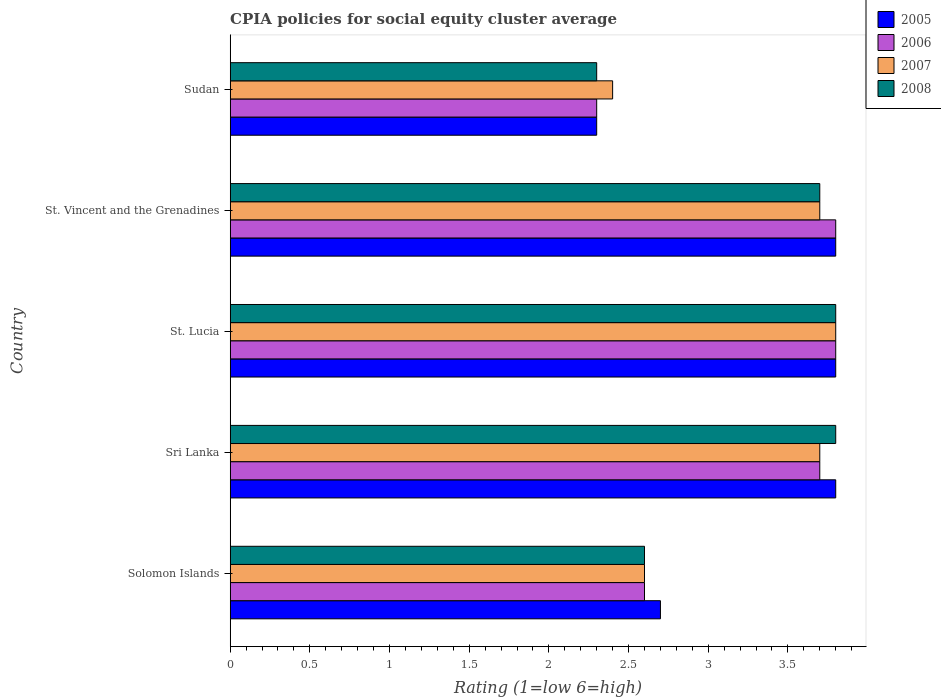How many different coloured bars are there?
Your answer should be very brief. 4. How many groups of bars are there?
Ensure brevity in your answer.  5. Are the number of bars per tick equal to the number of legend labels?
Your answer should be compact. Yes. Are the number of bars on each tick of the Y-axis equal?
Give a very brief answer. Yes. How many bars are there on the 4th tick from the top?
Your answer should be very brief. 4. How many bars are there on the 3rd tick from the bottom?
Provide a short and direct response. 4. What is the label of the 2nd group of bars from the top?
Provide a succinct answer. St. Vincent and the Grenadines. In how many cases, is the number of bars for a given country not equal to the number of legend labels?
Offer a terse response. 0. What is the CPIA rating in 2006 in Solomon Islands?
Provide a short and direct response. 2.6. In which country was the CPIA rating in 2005 maximum?
Make the answer very short. Sri Lanka. In which country was the CPIA rating in 2006 minimum?
Offer a terse response. Sudan. What is the total CPIA rating in 2008 in the graph?
Make the answer very short. 16.2. What is the difference between the CPIA rating in 2005 in Sri Lanka and that in St. Vincent and the Grenadines?
Offer a very short reply. 0. What is the difference between the CPIA rating in 2008 in St. Lucia and the CPIA rating in 2007 in Solomon Islands?
Make the answer very short. 1.2. What is the average CPIA rating in 2006 per country?
Provide a succinct answer. 3.24. What is the difference between the CPIA rating in 2005 and CPIA rating in 2007 in Solomon Islands?
Your answer should be compact. 0.1. In how many countries, is the CPIA rating in 2008 greater than 1.9 ?
Give a very brief answer. 5. What is the ratio of the CPIA rating in 2006 in Solomon Islands to that in Sri Lanka?
Provide a succinct answer. 0.7. Is the CPIA rating in 2005 in St. Vincent and the Grenadines less than that in Sudan?
Ensure brevity in your answer.  No. Is the difference between the CPIA rating in 2005 in Solomon Islands and Sudan greater than the difference between the CPIA rating in 2007 in Solomon Islands and Sudan?
Your response must be concise. Yes. What is the difference between the highest and the second highest CPIA rating in 2005?
Your answer should be very brief. 0. What is the difference between the highest and the lowest CPIA rating in 2005?
Give a very brief answer. 1.5. Is the sum of the CPIA rating in 2007 in Sri Lanka and Sudan greater than the maximum CPIA rating in 2005 across all countries?
Provide a succinct answer. Yes. Is it the case that in every country, the sum of the CPIA rating in 2007 and CPIA rating in 2005 is greater than the sum of CPIA rating in 2006 and CPIA rating in 2008?
Your answer should be compact. No. How many bars are there?
Offer a terse response. 20. How many countries are there in the graph?
Provide a short and direct response. 5. What is the difference between two consecutive major ticks on the X-axis?
Your answer should be compact. 0.5. Are the values on the major ticks of X-axis written in scientific E-notation?
Ensure brevity in your answer.  No. Does the graph contain any zero values?
Your response must be concise. No. Does the graph contain grids?
Give a very brief answer. No. Where does the legend appear in the graph?
Provide a succinct answer. Top right. How many legend labels are there?
Your answer should be very brief. 4. What is the title of the graph?
Your answer should be very brief. CPIA policies for social equity cluster average. What is the label or title of the X-axis?
Offer a terse response. Rating (1=low 6=high). What is the Rating (1=low 6=high) of 2006 in Sri Lanka?
Ensure brevity in your answer.  3.7. What is the Rating (1=low 6=high) of 2008 in Sri Lanka?
Your answer should be very brief. 3.8. What is the Rating (1=low 6=high) of 2005 in St. Lucia?
Your response must be concise. 3.8. What is the Rating (1=low 6=high) in 2006 in St. Lucia?
Your answer should be very brief. 3.8. What is the Rating (1=low 6=high) of 2007 in St. Lucia?
Provide a short and direct response. 3.8. What is the Rating (1=low 6=high) of 2006 in St. Vincent and the Grenadines?
Your response must be concise. 3.8. What is the Rating (1=low 6=high) in 2007 in St. Vincent and the Grenadines?
Your answer should be very brief. 3.7. What is the Rating (1=low 6=high) of 2008 in Sudan?
Your response must be concise. 2.3. Across all countries, what is the maximum Rating (1=low 6=high) in 2005?
Provide a short and direct response. 3.8. Across all countries, what is the minimum Rating (1=low 6=high) of 2007?
Your answer should be very brief. 2.4. What is the total Rating (1=low 6=high) in 2005 in the graph?
Give a very brief answer. 16.4. What is the total Rating (1=low 6=high) in 2006 in the graph?
Offer a terse response. 16.2. What is the total Rating (1=low 6=high) in 2008 in the graph?
Your answer should be compact. 16.2. What is the difference between the Rating (1=low 6=high) of 2005 in Solomon Islands and that in Sri Lanka?
Provide a short and direct response. -1.1. What is the difference between the Rating (1=low 6=high) of 2008 in Solomon Islands and that in Sri Lanka?
Your response must be concise. -1.2. What is the difference between the Rating (1=low 6=high) in 2005 in Solomon Islands and that in St. Lucia?
Make the answer very short. -1.1. What is the difference between the Rating (1=low 6=high) of 2006 in Solomon Islands and that in St. Lucia?
Your answer should be very brief. -1.2. What is the difference between the Rating (1=low 6=high) in 2006 in Solomon Islands and that in St. Vincent and the Grenadines?
Your response must be concise. -1.2. What is the difference between the Rating (1=low 6=high) of 2007 in Solomon Islands and that in St. Vincent and the Grenadines?
Give a very brief answer. -1.1. What is the difference between the Rating (1=low 6=high) in 2005 in Solomon Islands and that in Sudan?
Provide a succinct answer. 0.4. What is the difference between the Rating (1=low 6=high) in 2006 in Solomon Islands and that in Sudan?
Your answer should be compact. 0.3. What is the difference between the Rating (1=low 6=high) in 2007 in Solomon Islands and that in Sudan?
Give a very brief answer. 0.2. What is the difference between the Rating (1=low 6=high) of 2005 in Sri Lanka and that in St. Lucia?
Give a very brief answer. 0. What is the difference between the Rating (1=low 6=high) in 2008 in Sri Lanka and that in St. Lucia?
Offer a terse response. 0. What is the difference between the Rating (1=low 6=high) of 2005 in Sri Lanka and that in Sudan?
Your answer should be compact. 1.5. What is the difference between the Rating (1=low 6=high) of 2007 in Sri Lanka and that in Sudan?
Provide a succinct answer. 1.3. What is the difference between the Rating (1=low 6=high) of 2007 in St. Lucia and that in St. Vincent and the Grenadines?
Your answer should be very brief. 0.1. What is the difference between the Rating (1=low 6=high) of 2005 in St. Lucia and that in Sudan?
Offer a very short reply. 1.5. What is the difference between the Rating (1=low 6=high) in 2007 in St. Lucia and that in Sudan?
Offer a very short reply. 1.4. What is the difference between the Rating (1=low 6=high) of 2008 in St. Lucia and that in Sudan?
Provide a succinct answer. 1.5. What is the difference between the Rating (1=low 6=high) of 2006 in Solomon Islands and the Rating (1=low 6=high) of 2007 in Sri Lanka?
Your answer should be compact. -1.1. What is the difference between the Rating (1=low 6=high) of 2005 in Solomon Islands and the Rating (1=low 6=high) of 2007 in St. Lucia?
Make the answer very short. -1.1. What is the difference between the Rating (1=low 6=high) in 2006 in Solomon Islands and the Rating (1=low 6=high) in 2007 in St. Lucia?
Provide a succinct answer. -1.2. What is the difference between the Rating (1=low 6=high) of 2007 in Solomon Islands and the Rating (1=low 6=high) of 2008 in St. Lucia?
Make the answer very short. -1.2. What is the difference between the Rating (1=low 6=high) of 2005 in Solomon Islands and the Rating (1=low 6=high) of 2006 in St. Vincent and the Grenadines?
Provide a succinct answer. -1.1. What is the difference between the Rating (1=low 6=high) of 2005 in Solomon Islands and the Rating (1=low 6=high) of 2007 in St. Vincent and the Grenadines?
Provide a short and direct response. -1. What is the difference between the Rating (1=low 6=high) in 2005 in Solomon Islands and the Rating (1=low 6=high) in 2008 in St. Vincent and the Grenadines?
Ensure brevity in your answer.  -1. What is the difference between the Rating (1=low 6=high) of 2006 in Solomon Islands and the Rating (1=low 6=high) of 2007 in St. Vincent and the Grenadines?
Provide a short and direct response. -1.1. What is the difference between the Rating (1=low 6=high) of 2007 in Solomon Islands and the Rating (1=low 6=high) of 2008 in St. Vincent and the Grenadines?
Make the answer very short. -1.1. What is the difference between the Rating (1=low 6=high) in 2005 in Solomon Islands and the Rating (1=low 6=high) in 2006 in Sudan?
Provide a short and direct response. 0.4. What is the difference between the Rating (1=low 6=high) in 2006 in Solomon Islands and the Rating (1=low 6=high) in 2007 in Sudan?
Give a very brief answer. 0.2. What is the difference between the Rating (1=low 6=high) of 2006 in Solomon Islands and the Rating (1=low 6=high) of 2008 in Sudan?
Keep it short and to the point. 0.3. What is the difference between the Rating (1=low 6=high) in 2007 in Solomon Islands and the Rating (1=low 6=high) in 2008 in Sudan?
Ensure brevity in your answer.  0.3. What is the difference between the Rating (1=low 6=high) in 2005 in Sri Lanka and the Rating (1=low 6=high) in 2006 in St. Lucia?
Your answer should be compact. 0. What is the difference between the Rating (1=low 6=high) of 2005 in Sri Lanka and the Rating (1=low 6=high) of 2007 in St. Lucia?
Provide a succinct answer. 0. What is the difference between the Rating (1=low 6=high) of 2005 in Sri Lanka and the Rating (1=low 6=high) of 2008 in St. Lucia?
Ensure brevity in your answer.  0. What is the difference between the Rating (1=low 6=high) in 2006 in Sri Lanka and the Rating (1=low 6=high) in 2008 in St. Lucia?
Provide a short and direct response. -0.1. What is the difference between the Rating (1=low 6=high) in 2007 in Sri Lanka and the Rating (1=low 6=high) in 2008 in St. Lucia?
Offer a very short reply. -0.1. What is the difference between the Rating (1=low 6=high) in 2005 in Sri Lanka and the Rating (1=low 6=high) in 2006 in St. Vincent and the Grenadines?
Offer a very short reply. 0. What is the difference between the Rating (1=low 6=high) of 2005 in Sri Lanka and the Rating (1=low 6=high) of 2008 in St. Vincent and the Grenadines?
Provide a short and direct response. 0.1. What is the difference between the Rating (1=low 6=high) in 2006 in Sri Lanka and the Rating (1=low 6=high) in 2007 in St. Vincent and the Grenadines?
Give a very brief answer. 0. What is the difference between the Rating (1=low 6=high) in 2005 in Sri Lanka and the Rating (1=low 6=high) in 2006 in Sudan?
Ensure brevity in your answer.  1.5. What is the difference between the Rating (1=low 6=high) of 2005 in Sri Lanka and the Rating (1=low 6=high) of 2007 in Sudan?
Give a very brief answer. 1.4. What is the difference between the Rating (1=low 6=high) of 2005 in Sri Lanka and the Rating (1=low 6=high) of 2008 in Sudan?
Make the answer very short. 1.5. What is the difference between the Rating (1=low 6=high) in 2006 in Sri Lanka and the Rating (1=low 6=high) in 2007 in Sudan?
Provide a short and direct response. 1.3. What is the difference between the Rating (1=low 6=high) in 2006 in Sri Lanka and the Rating (1=low 6=high) in 2008 in Sudan?
Your answer should be compact. 1.4. What is the difference between the Rating (1=low 6=high) of 2005 in St. Lucia and the Rating (1=low 6=high) of 2007 in St. Vincent and the Grenadines?
Your answer should be very brief. 0.1. What is the difference between the Rating (1=low 6=high) of 2005 in St. Lucia and the Rating (1=low 6=high) of 2008 in St. Vincent and the Grenadines?
Your answer should be very brief. 0.1. What is the difference between the Rating (1=low 6=high) in 2005 in St. Lucia and the Rating (1=low 6=high) in 2006 in Sudan?
Your answer should be compact. 1.5. What is the difference between the Rating (1=low 6=high) in 2005 in St. Lucia and the Rating (1=low 6=high) in 2007 in Sudan?
Provide a short and direct response. 1.4. What is the difference between the Rating (1=low 6=high) of 2005 in St. Vincent and the Grenadines and the Rating (1=low 6=high) of 2006 in Sudan?
Give a very brief answer. 1.5. What is the difference between the Rating (1=low 6=high) of 2005 in St. Vincent and the Grenadines and the Rating (1=low 6=high) of 2007 in Sudan?
Give a very brief answer. 1.4. What is the difference between the Rating (1=low 6=high) of 2007 in St. Vincent and the Grenadines and the Rating (1=low 6=high) of 2008 in Sudan?
Offer a terse response. 1.4. What is the average Rating (1=low 6=high) in 2005 per country?
Provide a short and direct response. 3.28. What is the average Rating (1=low 6=high) of 2006 per country?
Ensure brevity in your answer.  3.24. What is the average Rating (1=low 6=high) in 2007 per country?
Your answer should be compact. 3.24. What is the average Rating (1=low 6=high) in 2008 per country?
Provide a succinct answer. 3.24. What is the difference between the Rating (1=low 6=high) of 2005 and Rating (1=low 6=high) of 2006 in Solomon Islands?
Give a very brief answer. 0.1. What is the difference between the Rating (1=low 6=high) of 2006 and Rating (1=low 6=high) of 2007 in Solomon Islands?
Offer a terse response. 0. What is the difference between the Rating (1=low 6=high) in 2007 and Rating (1=low 6=high) in 2008 in Solomon Islands?
Give a very brief answer. 0. What is the difference between the Rating (1=low 6=high) of 2005 and Rating (1=low 6=high) of 2006 in Sri Lanka?
Ensure brevity in your answer.  0.1. What is the difference between the Rating (1=low 6=high) in 2006 and Rating (1=low 6=high) in 2008 in Sri Lanka?
Ensure brevity in your answer.  -0.1. What is the difference between the Rating (1=low 6=high) of 2007 and Rating (1=low 6=high) of 2008 in Sri Lanka?
Provide a succinct answer. -0.1. What is the difference between the Rating (1=low 6=high) in 2005 and Rating (1=low 6=high) in 2006 in St. Lucia?
Give a very brief answer. 0. What is the difference between the Rating (1=low 6=high) in 2005 and Rating (1=low 6=high) in 2007 in St. Lucia?
Offer a terse response. 0. What is the difference between the Rating (1=low 6=high) in 2005 and Rating (1=low 6=high) in 2008 in St. Lucia?
Your answer should be very brief. 0. What is the difference between the Rating (1=low 6=high) in 2006 and Rating (1=low 6=high) in 2007 in St. Lucia?
Provide a short and direct response. 0. What is the difference between the Rating (1=low 6=high) in 2007 and Rating (1=low 6=high) in 2008 in St. Lucia?
Your answer should be very brief. 0. What is the difference between the Rating (1=low 6=high) of 2005 and Rating (1=low 6=high) of 2006 in St. Vincent and the Grenadines?
Your response must be concise. 0. What is the difference between the Rating (1=low 6=high) in 2006 and Rating (1=low 6=high) in 2007 in St. Vincent and the Grenadines?
Ensure brevity in your answer.  0.1. What is the difference between the Rating (1=low 6=high) of 2005 and Rating (1=low 6=high) of 2007 in Sudan?
Give a very brief answer. -0.1. What is the difference between the Rating (1=low 6=high) in 2005 and Rating (1=low 6=high) in 2008 in Sudan?
Offer a terse response. 0. What is the difference between the Rating (1=low 6=high) in 2006 and Rating (1=low 6=high) in 2007 in Sudan?
Offer a terse response. -0.1. What is the difference between the Rating (1=low 6=high) in 2007 and Rating (1=low 6=high) in 2008 in Sudan?
Your answer should be compact. 0.1. What is the ratio of the Rating (1=low 6=high) in 2005 in Solomon Islands to that in Sri Lanka?
Your answer should be very brief. 0.71. What is the ratio of the Rating (1=low 6=high) in 2006 in Solomon Islands to that in Sri Lanka?
Make the answer very short. 0.7. What is the ratio of the Rating (1=low 6=high) in 2007 in Solomon Islands to that in Sri Lanka?
Give a very brief answer. 0.7. What is the ratio of the Rating (1=low 6=high) in 2008 in Solomon Islands to that in Sri Lanka?
Your answer should be compact. 0.68. What is the ratio of the Rating (1=low 6=high) in 2005 in Solomon Islands to that in St. Lucia?
Your response must be concise. 0.71. What is the ratio of the Rating (1=low 6=high) of 2006 in Solomon Islands to that in St. Lucia?
Your answer should be very brief. 0.68. What is the ratio of the Rating (1=low 6=high) of 2007 in Solomon Islands to that in St. Lucia?
Offer a terse response. 0.68. What is the ratio of the Rating (1=low 6=high) in 2008 in Solomon Islands to that in St. Lucia?
Offer a very short reply. 0.68. What is the ratio of the Rating (1=low 6=high) of 2005 in Solomon Islands to that in St. Vincent and the Grenadines?
Provide a succinct answer. 0.71. What is the ratio of the Rating (1=low 6=high) in 2006 in Solomon Islands to that in St. Vincent and the Grenadines?
Keep it short and to the point. 0.68. What is the ratio of the Rating (1=low 6=high) in 2007 in Solomon Islands to that in St. Vincent and the Grenadines?
Make the answer very short. 0.7. What is the ratio of the Rating (1=low 6=high) of 2008 in Solomon Islands to that in St. Vincent and the Grenadines?
Offer a terse response. 0.7. What is the ratio of the Rating (1=low 6=high) of 2005 in Solomon Islands to that in Sudan?
Offer a very short reply. 1.17. What is the ratio of the Rating (1=low 6=high) in 2006 in Solomon Islands to that in Sudan?
Provide a short and direct response. 1.13. What is the ratio of the Rating (1=low 6=high) of 2007 in Solomon Islands to that in Sudan?
Your answer should be very brief. 1.08. What is the ratio of the Rating (1=low 6=high) of 2008 in Solomon Islands to that in Sudan?
Your answer should be very brief. 1.13. What is the ratio of the Rating (1=low 6=high) in 2005 in Sri Lanka to that in St. Lucia?
Provide a short and direct response. 1. What is the ratio of the Rating (1=low 6=high) of 2006 in Sri Lanka to that in St. Lucia?
Your answer should be very brief. 0.97. What is the ratio of the Rating (1=low 6=high) of 2007 in Sri Lanka to that in St. Lucia?
Ensure brevity in your answer.  0.97. What is the ratio of the Rating (1=low 6=high) of 2008 in Sri Lanka to that in St. Lucia?
Keep it short and to the point. 1. What is the ratio of the Rating (1=low 6=high) of 2006 in Sri Lanka to that in St. Vincent and the Grenadines?
Give a very brief answer. 0.97. What is the ratio of the Rating (1=low 6=high) in 2007 in Sri Lanka to that in St. Vincent and the Grenadines?
Provide a short and direct response. 1. What is the ratio of the Rating (1=low 6=high) in 2008 in Sri Lanka to that in St. Vincent and the Grenadines?
Keep it short and to the point. 1.03. What is the ratio of the Rating (1=low 6=high) of 2005 in Sri Lanka to that in Sudan?
Your response must be concise. 1.65. What is the ratio of the Rating (1=low 6=high) of 2006 in Sri Lanka to that in Sudan?
Offer a terse response. 1.61. What is the ratio of the Rating (1=low 6=high) of 2007 in Sri Lanka to that in Sudan?
Offer a terse response. 1.54. What is the ratio of the Rating (1=low 6=high) in 2008 in Sri Lanka to that in Sudan?
Ensure brevity in your answer.  1.65. What is the ratio of the Rating (1=low 6=high) in 2008 in St. Lucia to that in St. Vincent and the Grenadines?
Offer a very short reply. 1.03. What is the ratio of the Rating (1=low 6=high) in 2005 in St. Lucia to that in Sudan?
Provide a succinct answer. 1.65. What is the ratio of the Rating (1=low 6=high) of 2006 in St. Lucia to that in Sudan?
Ensure brevity in your answer.  1.65. What is the ratio of the Rating (1=low 6=high) in 2007 in St. Lucia to that in Sudan?
Keep it short and to the point. 1.58. What is the ratio of the Rating (1=low 6=high) in 2008 in St. Lucia to that in Sudan?
Make the answer very short. 1.65. What is the ratio of the Rating (1=low 6=high) in 2005 in St. Vincent and the Grenadines to that in Sudan?
Provide a short and direct response. 1.65. What is the ratio of the Rating (1=low 6=high) of 2006 in St. Vincent and the Grenadines to that in Sudan?
Ensure brevity in your answer.  1.65. What is the ratio of the Rating (1=low 6=high) in 2007 in St. Vincent and the Grenadines to that in Sudan?
Ensure brevity in your answer.  1.54. What is the ratio of the Rating (1=low 6=high) of 2008 in St. Vincent and the Grenadines to that in Sudan?
Keep it short and to the point. 1.61. What is the difference between the highest and the second highest Rating (1=low 6=high) of 2007?
Keep it short and to the point. 0.1. What is the difference between the highest and the lowest Rating (1=low 6=high) in 2005?
Keep it short and to the point. 1.5. 